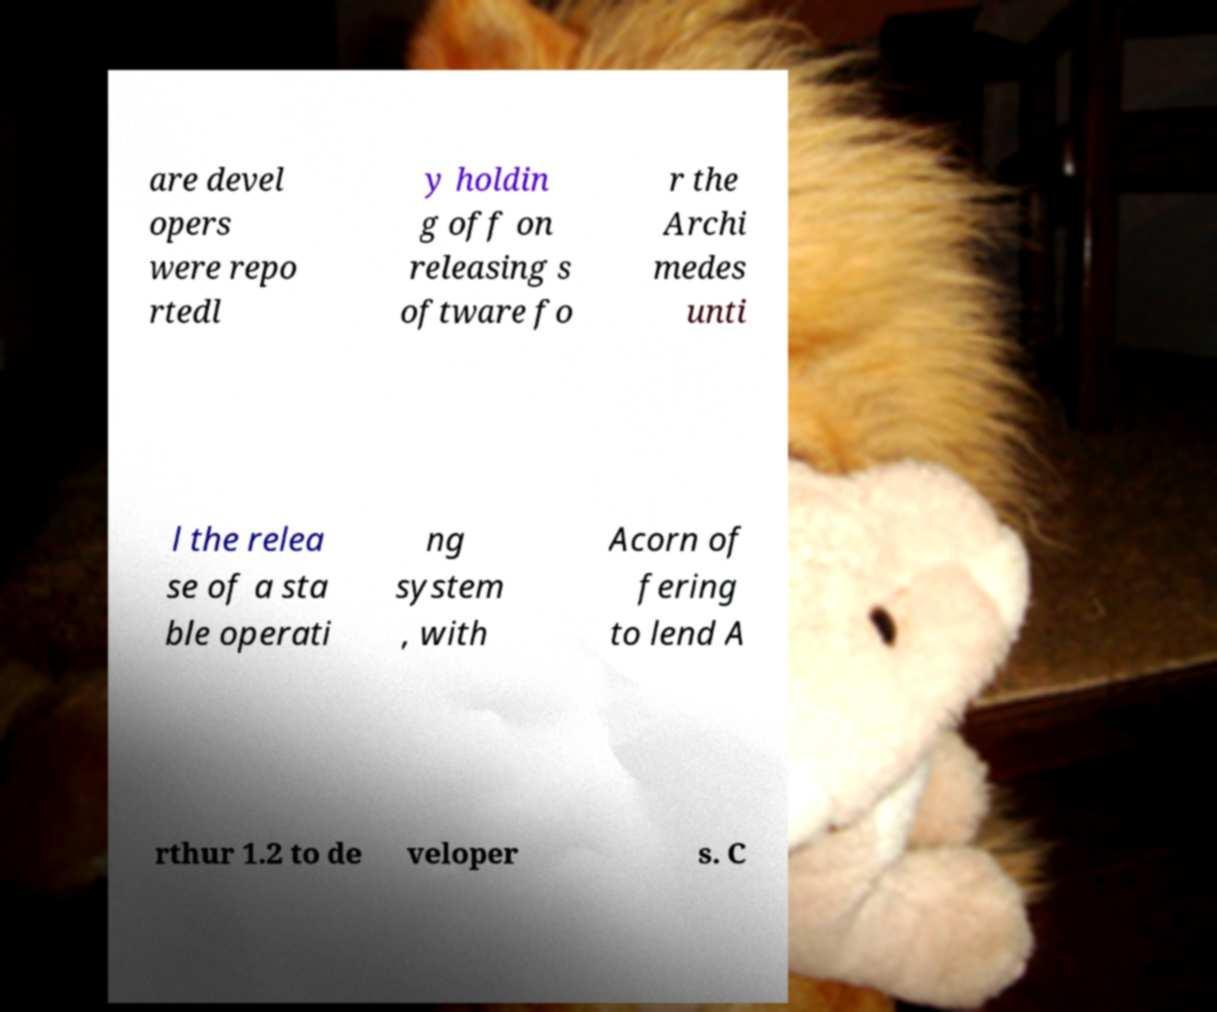I need the written content from this picture converted into text. Can you do that? are devel opers were repo rtedl y holdin g off on releasing s oftware fo r the Archi medes unti l the relea se of a sta ble operati ng system , with Acorn of fering to lend A rthur 1.2 to de veloper s. C 